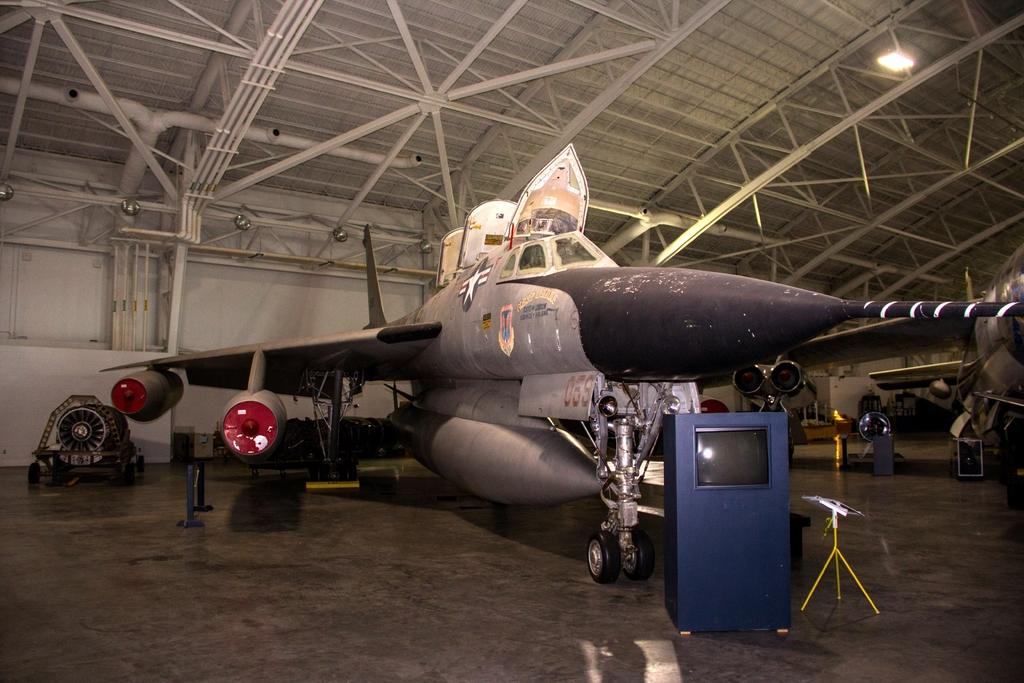What is located on the ground in the image? There are airplanes on the ground in the image. What structure can be seen in the image? There is a stand in the image. What objects are present in the image besides the airplanes and stand? There are boxes and rods visible in the image. What can be seen in the background of the image? There is a wall visible in the background of the image. Where is the tub located in the image? There is no tub present in the image. What type of furniture can be seen in the bedroom in the image? There is no bedroom or furniture present in the image. 